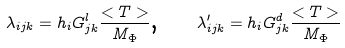<formula> <loc_0><loc_0><loc_500><loc_500>\lambda _ { i j k } = h _ { i } G _ { j k } ^ { l } \frac { < T > } { M _ { \Phi } } \text {, \quad } \lambda _ { i j k } ^ { \prime } = h _ { i } G _ { j k } ^ { d } \frac { < T > } { M _ { \Phi } }</formula> 